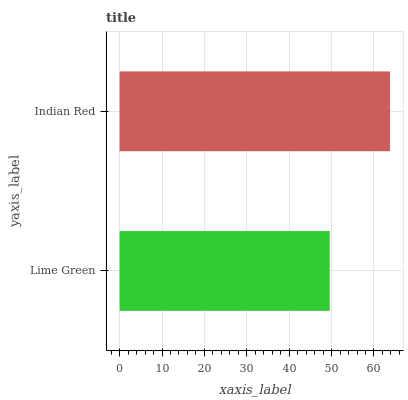Is Lime Green the minimum?
Answer yes or no. Yes. Is Indian Red the maximum?
Answer yes or no. Yes. Is Indian Red the minimum?
Answer yes or no. No. Is Indian Red greater than Lime Green?
Answer yes or no. Yes. Is Lime Green less than Indian Red?
Answer yes or no. Yes. Is Lime Green greater than Indian Red?
Answer yes or no. No. Is Indian Red less than Lime Green?
Answer yes or no. No. Is Indian Red the high median?
Answer yes or no. Yes. Is Lime Green the low median?
Answer yes or no. Yes. Is Lime Green the high median?
Answer yes or no. No. Is Indian Red the low median?
Answer yes or no. No. 